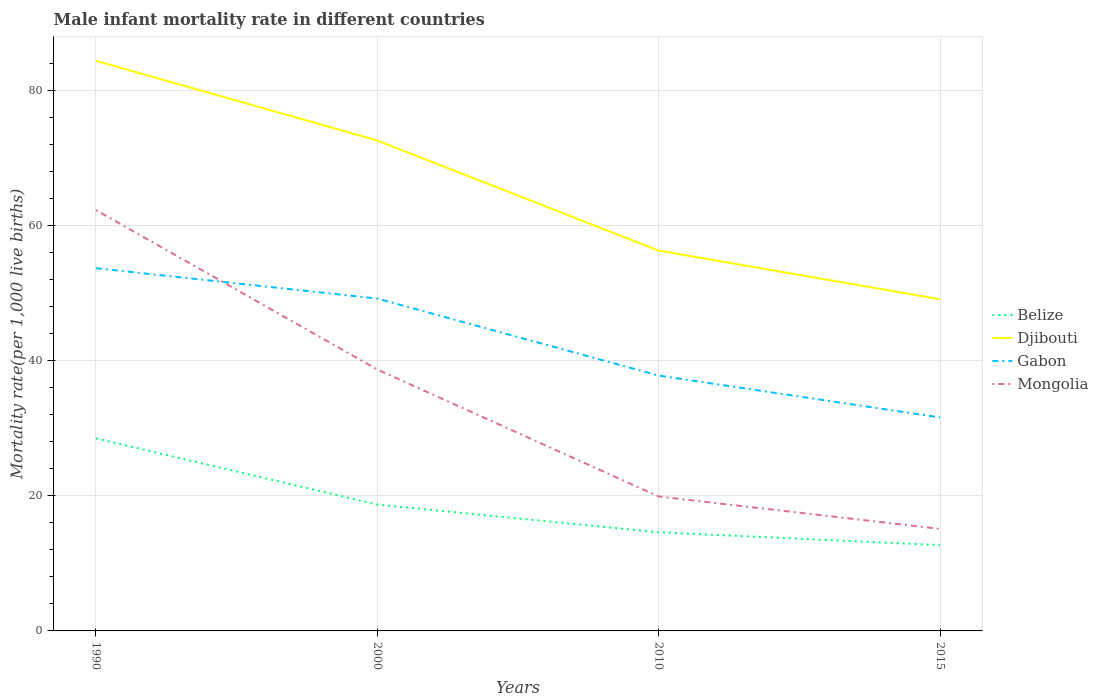Does the line corresponding to Gabon intersect with the line corresponding to Mongolia?
Offer a terse response. Yes. Across all years, what is the maximum male infant mortality rate in Djibouti?
Your answer should be compact. 49.1. In which year was the male infant mortality rate in Mongolia maximum?
Your response must be concise. 2015. What is the total male infant mortality rate in Djibouti in the graph?
Your answer should be very brief. 7.2. What is the difference between the highest and the second highest male infant mortality rate in Djibouti?
Make the answer very short. 35.3. What is the difference between the highest and the lowest male infant mortality rate in Belize?
Keep it short and to the point. 2. How many years are there in the graph?
Offer a very short reply. 4. Where does the legend appear in the graph?
Your answer should be very brief. Center right. What is the title of the graph?
Offer a very short reply. Male infant mortality rate in different countries. What is the label or title of the X-axis?
Ensure brevity in your answer.  Years. What is the label or title of the Y-axis?
Offer a terse response. Mortality rate(per 1,0 live births). What is the Mortality rate(per 1,000 live births) of Djibouti in 1990?
Keep it short and to the point. 84.4. What is the Mortality rate(per 1,000 live births) of Gabon in 1990?
Ensure brevity in your answer.  53.7. What is the Mortality rate(per 1,000 live births) of Mongolia in 1990?
Your answer should be compact. 62.3. What is the Mortality rate(per 1,000 live births) in Djibouti in 2000?
Your answer should be compact. 72.6. What is the Mortality rate(per 1,000 live births) in Gabon in 2000?
Your answer should be compact. 49.2. What is the Mortality rate(per 1,000 live births) in Mongolia in 2000?
Provide a short and direct response. 38.7. What is the Mortality rate(per 1,000 live births) of Belize in 2010?
Your answer should be compact. 14.6. What is the Mortality rate(per 1,000 live births) in Djibouti in 2010?
Your answer should be compact. 56.3. What is the Mortality rate(per 1,000 live births) of Gabon in 2010?
Ensure brevity in your answer.  37.8. What is the Mortality rate(per 1,000 live births) in Belize in 2015?
Keep it short and to the point. 12.7. What is the Mortality rate(per 1,000 live births) of Djibouti in 2015?
Give a very brief answer. 49.1. What is the Mortality rate(per 1,000 live births) of Gabon in 2015?
Provide a succinct answer. 31.6. Across all years, what is the maximum Mortality rate(per 1,000 live births) of Djibouti?
Your response must be concise. 84.4. Across all years, what is the maximum Mortality rate(per 1,000 live births) of Gabon?
Give a very brief answer. 53.7. Across all years, what is the maximum Mortality rate(per 1,000 live births) of Mongolia?
Make the answer very short. 62.3. Across all years, what is the minimum Mortality rate(per 1,000 live births) of Belize?
Ensure brevity in your answer.  12.7. Across all years, what is the minimum Mortality rate(per 1,000 live births) of Djibouti?
Keep it short and to the point. 49.1. Across all years, what is the minimum Mortality rate(per 1,000 live births) of Gabon?
Provide a succinct answer. 31.6. What is the total Mortality rate(per 1,000 live births) in Belize in the graph?
Ensure brevity in your answer.  74.5. What is the total Mortality rate(per 1,000 live births) of Djibouti in the graph?
Ensure brevity in your answer.  262.4. What is the total Mortality rate(per 1,000 live births) in Gabon in the graph?
Offer a very short reply. 172.3. What is the total Mortality rate(per 1,000 live births) of Mongolia in the graph?
Provide a succinct answer. 136. What is the difference between the Mortality rate(per 1,000 live births) of Djibouti in 1990 and that in 2000?
Provide a short and direct response. 11.8. What is the difference between the Mortality rate(per 1,000 live births) of Mongolia in 1990 and that in 2000?
Your response must be concise. 23.6. What is the difference between the Mortality rate(per 1,000 live births) in Belize in 1990 and that in 2010?
Your answer should be compact. 13.9. What is the difference between the Mortality rate(per 1,000 live births) in Djibouti in 1990 and that in 2010?
Give a very brief answer. 28.1. What is the difference between the Mortality rate(per 1,000 live births) of Mongolia in 1990 and that in 2010?
Your answer should be very brief. 42.4. What is the difference between the Mortality rate(per 1,000 live births) in Djibouti in 1990 and that in 2015?
Give a very brief answer. 35.3. What is the difference between the Mortality rate(per 1,000 live births) in Gabon in 1990 and that in 2015?
Your response must be concise. 22.1. What is the difference between the Mortality rate(per 1,000 live births) in Mongolia in 1990 and that in 2015?
Offer a very short reply. 47.2. What is the difference between the Mortality rate(per 1,000 live births) of Belize in 2000 and that in 2010?
Provide a succinct answer. 4.1. What is the difference between the Mortality rate(per 1,000 live births) in Belize in 2000 and that in 2015?
Your response must be concise. 6. What is the difference between the Mortality rate(per 1,000 live births) of Djibouti in 2000 and that in 2015?
Your response must be concise. 23.5. What is the difference between the Mortality rate(per 1,000 live births) in Gabon in 2000 and that in 2015?
Offer a terse response. 17.6. What is the difference between the Mortality rate(per 1,000 live births) in Mongolia in 2000 and that in 2015?
Make the answer very short. 23.6. What is the difference between the Mortality rate(per 1,000 live births) of Belize in 2010 and that in 2015?
Keep it short and to the point. 1.9. What is the difference between the Mortality rate(per 1,000 live births) in Gabon in 2010 and that in 2015?
Offer a terse response. 6.2. What is the difference between the Mortality rate(per 1,000 live births) in Mongolia in 2010 and that in 2015?
Your answer should be very brief. 4.8. What is the difference between the Mortality rate(per 1,000 live births) in Belize in 1990 and the Mortality rate(per 1,000 live births) in Djibouti in 2000?
Offer a very short reply. -44.1. What is the difference between the Mortality rate(per 1,000 live births) in Belize in 1990 and the Mortality rate(per 1,000 live births) in Gabon in 2000?
Make the answer very short. -20.7. What is the difference between the Mortality rate(per 1,000 live births) in Djibouti in 1990 and the Mortality rate(per 1,000 live births) in Gabon in 2000?
Keep it short and to the point. 35.2. What is the difference between the Mortality rate(per 1,000 live births) of Djibouti in 1990 and the Mortality rate(per 1,000 live births) of Mongolia in 2000?
Your answer should be very brief. 45.7. What is the difference between the Mortality rate(per 1,000 live births) of Gabon in 1990 and the Mortality rate(per 1,000 live births) of Mongolia in 2000?
Provide a short and direct response. 15. What is the difference between the Mortality rate(per 1,000 live births) of Belize in 1990 and the Mortality rate(per 1,000 live births) of Djibouti in 2010?
Provide a short and direct response. -27.8. What is the difference between the Mortality rate(per 1,000 live births) in Belize in 1990 and the Mortality rate(per 1,000 live births) in Gabon in 2010?
Offer a very short reply. -9.3. What is the difference between the Mortality rate(per 1,000 live births) of Belize in 1990 and the Mortality rate(per 1,000 live births) of Mongolia in 2010?
Ensure brevity in your answer.  8.6. What is the difference between the Mortality rate(per 1,000 live births) of Djibouti in 1990 and the Mortality rate(per 1,000 live births) of Gabon in 2010?
Provide a short and direct response. 46.6. What is the difference between the Mortality rate(per 1,000 live births) in Djibouti in 1990 and the Mortality rate(per 1,000 live births) in Mongolia in 2010?
Ensure brevity in your answer.  64.5. What is the difference between the Mortality rate(per 1,000 live births) of Gabon in 1990 and the Mortality rate(per 1,000 live births) of Mongolia in 2010?
Your answer should be compact. 33.8. What is the difference between the Mortality rate(per 1,000 live births) in Belize in 1990 and the Mortality rate(per 1,000 live births) in Djibouti in 2015?
Offer a terse response. -20.6. What is the difference between the Mortality rate(per 1,000 live births) of Belize in 1990 and the Mortality rate(per 1,000 live births) of Mongolia in 2015?
Ensure brevity in your answer.  13.4. What is the difference between the Mortality rate(per 1,000 live births) of Djibouti in 1990 and the Mortality rate(per 1,000 live births) of Gabon in 2015?
Your answer should be compact. 52.8. What is the difference between the Mortality rate(per 1,000 live births) in Djibouti in 1990 and the Mortality rate(per 1,000 live births) in Mongolia in 2015?
Offer a very short reply. 69.3. What is the difference between the Mortality rate(per 1,000 live births) in Gabon in 1990 and the Mortality rate(per 1,000 live births) in Mongolia in 2015?
Your answer should be very brief. 38.6. What is the difference between the Mortality rate(per 1,000 live births) of Belize in 2000 and the Mortality rate(per 1,000 live births) of Djibouti in 2010?
Your answer should be very brief. -37.6. What is the difference between the Mortality rate(per 1,000 live births) in Belize in 2000 and the Mortality rate(per 1,000 live births) in Gabon in 2010?
Your response must be concise. -19.1. What is the difference between the Mortality rate(per 1,000 live births) in Djibouti in 2000 and the Mortality rate(per 1,000 live births) in Gabon in 2010?
Keep it short and to the point. 34.8. What is the difference between the Mortality rate(per 1,000 live births) of Djibouti in 2000 and the Mortality rate(per 1,000 live births) of Mongolia in 2010?
Provide a short and direct response. 52.7. What is the difference between the Mortality rate(per 1,000 live births) in Gabon in 2000 and the Mortality rate(per 1,000 live births) in Mongolia in 2010?
Give a very brief answer. 29.3. What is the difference between the Mortality rate(per 1,000 live births) in Belize in 2000 and the Mortality rate(per 1,000 live births) in Djibouti in 2015?
Provide a short and direct response. -30.4. What is the difference between the Mortality rate(per 1,000 live births) in Belize in 2000 and the Mortality rate(per 1,000 live births) in Gabon in 2015?
Offer a terse response. -12.9. What is the difference between the Mortality rate(per 1,000 live births) of Djibouti in 2000 and the Mortality rate(per 1,000 live births) of Gabon in 2015?
Your answer should be compact. 41. What is the difference between the Mortality rate(per 1,000 live births) in Djibouti in 2000 and the Mortality rate(per 1,000 live births) in Mongolia in 2015?
Make the answer very short. 57.5. What is the difference between the Mortality rate(per 1,000 live births) in Gabon in 2000 and the Mortality rate(per 1,000 live births) in Mongolia in 2015?
Keep it short and to the point. 34.1. What is the difference between the Mortality rate(per 1,000 live births) of Belize in 2010 and the Mortality rate(per 1,000 live births) of Djibouti in 2015?
Provide a succinct answer. -34.5. What is the difference between the Mortality rate(per 1,000 live births) of Belize in 2010 and the Mortality rate(per 1,000 live births) of Mongolia in 2015?
Your answer should be very brief. -0.5. What is the difference between the Mortality rate(per 1,000 live births) of Djibouti in 2010 and the Mortality rate(per 1,000 live births) of Gabon in 2015?
Your response must be concise. 24.7. What is the difference between the Mortality rate(per 1,000 live births) in Djibouti in 2010 and the Mortality rate(per 1,000 live births) in Mongolia in 2015?
Keep it short and to the point. 41.2. What is the difference between the Mortality rate(per 1,000 live births) in Gabon in 2010 and the Mortality rate(per 1,000 live births) in Mongolia in 2015?
Your response must be concise. 22.7. What is the average Mortality rate(per 1,000 live births) of Belize per year?
Provide a succinct answer. 18.62. What is the average Mortality rate(per 1,000 live births) of Djibouti per year?
Ensure brevity in your answer.  65.6. What is the average Mortality rate(per 1,000 live births) of Gabon per year?
Give a very brief answer. 43.08. In the year 1990, what is the difference between the Mortality rate(per 1,000 live births) of Belize and Mortality rate(per 1,000 live births) of Djibouti?
Your response must be concise. -55.9. In the year 1990, what is the difference between the Mortality rate(per 1,000 live births) in Belize and Mortality rate(per 1,000 live births) in Gabon?
Offer a very short reply. -25.2. In the year 1990, what is the difference between the Mortality rate(per 1,000 live births) in Belize and Mortality rate(per 1,000 live births) in Mongolia?
Ensure brevity in your answer.  -33.8. In the year 1990, what is the difference between the Mortality rate(per 1,000 live births) of Djibouti and Mortality rate(per 1,000 live births) of Gabon?
Make the answer very short. 30.7. In the year 1990, what is the difference between the Mortality rate(per 1,000 live births) in Djibouti and Mortality rate(per 1,000 live births) in Mongolia?
Your response must be concise. 22.1. In the year 1990, what is the difference between the Mortality rate(per 1,000 live births) in Gabon and Mortality rate(per 1,000 live births) in Mongolia?
Provide a short and direct response. -8.6. In the year 2000, what is the difference between the Mortality rate(per 1,000 live births) in Belize and Mortality rate(per 1,000 live births) in Djibouti?
Offer a terse response. -53.9. In the year 2000, what is the difference between the Mortality rate(per 1,000 live births) in Belize and Mortality rate(per 1,000 live births) in Gabon?
Your response must be concise. -30.5. In the year 2000, what is the difference between the Mortality rate(per 1,000 live births) in Belize and Mortality rate(per 1,000 live births) in Mongolia?
Make the answer very short. -20. In the year 2000, what is the difference between the Mortality rate(per 1,000 live births) of Djibouti and Mortality rate(per 1,000 live births) of Gabon?
Your answer should be very brief. 23.4. In the year 2000, what is the difference between the Mortality rate(per 1,000 live births) of Djibouti and Mortality rate(per 1,000 live births) of Mongolia?
Your answer should be compact. 33.9. In the year 2010, what is the difference between the Mortality rate(per 1,000 live births) of Belize and Mortality rate(per 1,000 live births) of Djibouti?
Provide a short and direct response. -41.7. In the year 2010, what is the difference between the Mortality rate(per 1,000 live births) of Belize and Mortality rate(per 1,000 live births) of Gabon?
Provide a succinct answer. -23.2. In the year 2010, what is the difference between the Mortality rate(per 1,000 live births) of Djibouti and Mortality rate(per 1,000 live births) of Gabon?
Offer a very short reply. 18.5. In the year 2010, what is the difference between the Mortality rate(per 1,000 live births) of Djibouti and Mortality rate(per 1,000 live births) of Mongolia?
Your answer should be very brief. 36.4. In the year 2010, what is the difference between the Mortality rate(per 1,000 live births) in Gabon and Mortality rate(per 1,000 live births) in Mongolia?
Offer a terse response. 17.9. In the year 2015, what is the difference between the Mortality rate(per 1,000 live births) of Belize and Mortality rate(per 1,000 live births) of Djibouti?
Your answer should be very brief. -36.4. In the year 2015, what is the difference between the Mortality rate(per 1,000 live births) of Belize and Mortality rate(per 1,000 live births) of Gabon?
Ensure brevity in your answer.  -18.9. In the year 2015, what is the difference between the Mortality rate(per 1,000 live births) of Djibouti and Mortality rate(per 1,000 live births) of Gabon?
Your response must be concise. 17.5. In the year 2015, what is the difference between the Mortality rate(per 1,000 live births) of Djibouti and Mortality rate(per 1,000 live births) of Mongolia?
Provide a succinct answer. 34. In the year 2015, what is the difference between the Mortality rate(per 1,000 live births) of Gabon and Mortality rate(per 1,000 live births) of Mongolia?
Ensure brevity in your answer.  16.5. What is the ratio of the Mortality rate(per 1,000 live births) in Belize in 1990 to that in 2000?
Your response must be concise. 1.52. What is the ratio of the Mortality rate(per 1,000 live births) of Djibouti in 1990 to that in 2000?
Your answer should be compact. 1.16. What is the ratio of the Mortality rate(per 1,000 live births) in Gabon in 1990 to that in 2000?
Your answer should be very brief. 1.09. What is the ratio of the Mortality rate(per 1,000 live births) in Mongolia in 1990 to that in 2000?
Offer a very short reply. 1.61. What is the ratio of the Mortality rate(per 1,000 live births) of Belize in 1990 to that in 2010?
Keep it short and to the point. 1.95. What is the ratio of the Mortality rate(per 1,000 live births) of Djibouti in 1990 to that in 2010?
Provide a succinct answer. 1.5. What is the ratio of the Mortality rate(per 1,000 live births) of Gabon in 1990 to that in 2010?
Your response must be concise. 1.42. What is the ratio of the Mortality rate(per 1,000 live births) in Mongolia in 1990 to that in 2010?
Your answer should be compact. 3.13. What is the ratio of the Mortality rate(per 1,000 live births) of Belize in 1990 to that in 2015?
Provide a short and direct response. 2.24. What is the ratio of the Mortality rate(per 1,000 live births) in Djibouti in 1990 to that in 2015?
Your response must be concise. 1.72. What is the ratio of the Mortality rate(per 1,000 live births) of Gabon in 1990 to that in 2015?
Give a very brief answer. 1.7. What is the ratio of the Mortality rate(per 1,000 live births) of Mongolia in 1990 to that in 2015?
Offer a terse response. 4.13. What is the ratio of the Mortality rate(per 1,000 live births) in Belize in 2000 to that in 2010?
Your answer should be compact. 1.28. What is the ratio of the Mortality rate(per 1,000 live births) of Djibouti in 2000 to that in 2010?
Keep it short and to the point. 1.29. What is the ratio of the Mortality rate(per 1,000 live births) in Gabon in 2000 to that in 2010?
Your response must be concise. 1.3. What is the ratio of the Mortality rate(per 1,000 live births) of Mongolia in 2000 to that in 2010?
Your answer should be compact. 1.94. What is the ratio of the Mortality rate(per 1,000 live births) in Belize in 2000 to that in 2015?
Provide a succinct answer. 1.47. What is the ratio of the Mortality rate(per 1,000 live births) of Djibouti in 2000 to that in 2015?
Provide a succinct answer. 1.48. What is the ratio of the Mortality rate(per 1,000 live births) in Gabon in 2000 to that in 2015?
Provide a succinct answer. 1.56. What is the ratio of the Mortality rate(per 1,000 live births) of Mongolia in 2000 to that in 2015?
Keep it short and to the point. 2.56. What is the ratio of the Mortality rate(per 1,000 live births) in Belize in 2010 to that in 2015?
Give a very brief answer. 1.15. What is the ratio of the Mortality rate(per 1,000 live births) of Djibouti in 2010 to that in 2015?
Your answer should be compact. 1.15. What is the ratio of the Mortality rate(per 1,000 live births) in Gabon in 2010 to that in 2015?
Offer a very short reply. 1.2. What is the ratio of the Mortality rate(per 1,000 live births) of Mongolia in 2010 to that in 2015?
Your response must be concise. 1.32. What is the difference between the highest and the second highest Mortality rate(per 1,000 live births) in Mongolia?
Give a very brief answer. 23.6. What is the difference between the highest and the lowest Mortality rate(per 1,000 live births) of Belize?
Offer a terse response. 15.8. What is the difference between the highest and the lowest Mortality rate(per 1,000 live births) of Djibouti?
Your answer should be compact. 35.3. What is the difference between the highest and the lowest Mortality rate(per 1,000 live births) of Gabon?
Your answer should be very brief. 22.1. What is the difference between the highest and the lowest Mortality rate(per 1,000 live births) in Mongolia?
Offer a terse response. 47.2. 